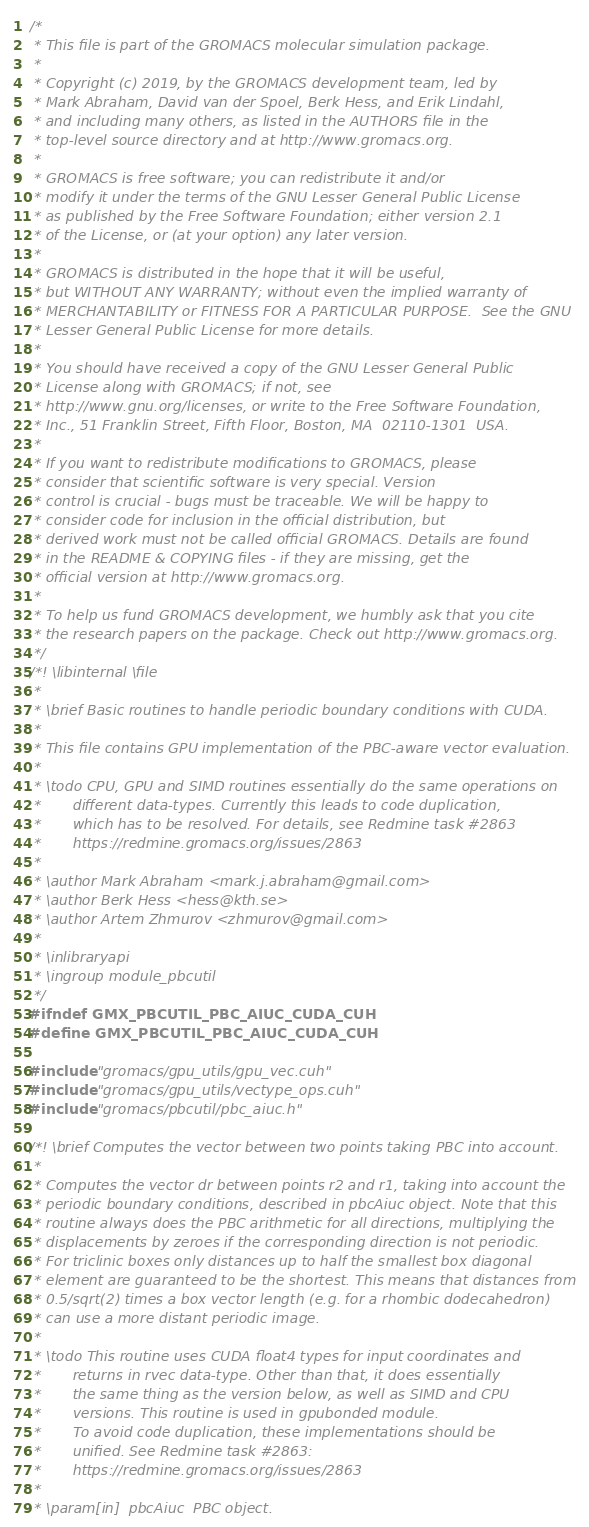Convert code to text. <code><loc_0><loc_0><loc_500><loc_500><_Cuda_>/*
 * This file is part of the GROMACS molecular simulation package.
 *
 * Copyright (c) 2019, by the GROMACS development team, led by
 * Mark Abraham, David van der Spoel, Berk Hess, and Erik Lindahl,
 * and including many others, as listed in the AUTHORS file in the
 * top-level source directory and at http://www.gromacs.org.
 *
 * GROMACS is free software; you can redistribute it and/or
 * modify it under the terms of the GNU Lesser General Public License
 * as published by the Free Software Foundation; either version 2.1
 * of the License, or (at your option) any later version.
 *
 * GROMACS is distributed in the hope that it will be useful,
 * but WITHOUT ANY WARRANTY; without even the implied warranty of
 * MERCHANTABILITY or FITNESS FOR A PARTICULAR PURPOSE.  See the GNU
 * Lesser General Public License for more details.
 *
 * You should have received a copy of the GNU Lesser General Public
 * License along with GROMACS; if not, see
 * http://www.gnu.org/licenses, or write to the Free Software Foundation,
 * Inc., 51 Franklin Street, Fifth Floor, Boston, MA  02110-1301  USA.
 *
 * If you want to redistribute modifications to GROMACS, please
 * consider that scientific software is very special. Version
 * control is crucial - bugs must be traceable. We will be happy to
 * consider code for inclusion in the official distribution, but
 * derived work must not be called official GROMACS. Details are found
 * in the README & COPYING files - if they are missing, get the
 * official version at http://www.gromacs.org.
 *
 * To help us fund GROMACS development, we humbly ask that you cite
 * the research papers on the package. Check out http://www.gromacs.org.
 */
/*! \libinternal \file
 *
 * \brief Basic routines to handle periodic boundary conditions with CUDA.
 *
 * This file contains GPU implementation of the PBC-aware vector evaluation.
 *
 * \todo CPU, GPU and SIMD routines essentially do the same operations on
 *       different data-types. Currently this leads to code duplication,
 *       which has to be resolved. For details, see Redmine task #2863
 *       https://redmine.gromacs.org/issues/2863
 *
 * \author Mark Abraham <mark.j.abraham@gmail.com>
 * \author Berk Hess <hess@kth.se>
 * \author Artem Zhmurov <zhmurov@gmail.com>
 *
 * \inlibraryapi
 * \ingroup module_pbcutil
 */
#ifndef GMX_PBCUTIL_PBC_AIUC_CUDA_CUH
#define GMX_PBCUTIL_PBC_AIUC_CUDA_CUH

#include "gromacs/gpu_utils/gpu_vec.cuh"
#include "gromacs/gpu_utils/vectype_ops.cuh"
#include "gromacs/pbcutil/pbc_aiuc.h"

/*! \brief Computes the vector between two points taking PBC into account.
 *
 * Computes the vector dr between points r2 and r1, taking into account the
 * periodic boundary conditions, described in pbcAiuc object. Note that this
 * routine always does the PBC arithmetic for all directions, multiplying the
 * displacements by zeroes if the corresponding direction is not periodic.
 * For triclinic boxes only distances up to half the smallest box diagonal
 * element are guaranteed to be the shortest. This means that distances from
 * 0.5/sqrt(2) times a box vector length (e.g. for a rhombic dodecahedron)
 * can use a more distant periodic image.
 *
 * \todo This routine uses CUDA float4 types for input coordinates and
 *       returns in rvec data-type. Other than that, it does essentially
 *       the same thing as the version below, as well as SIMD and CPU
 *       versions. This routine is used in gpubonded module.
 *       To avoid code duplication, these implementations should be
 *       unified. See Redmine task #2863:
 *       https://redmine.gromacs.org/issues/2863
 *
 * \param[in]  pbcAiuc  PBC object.</code> 